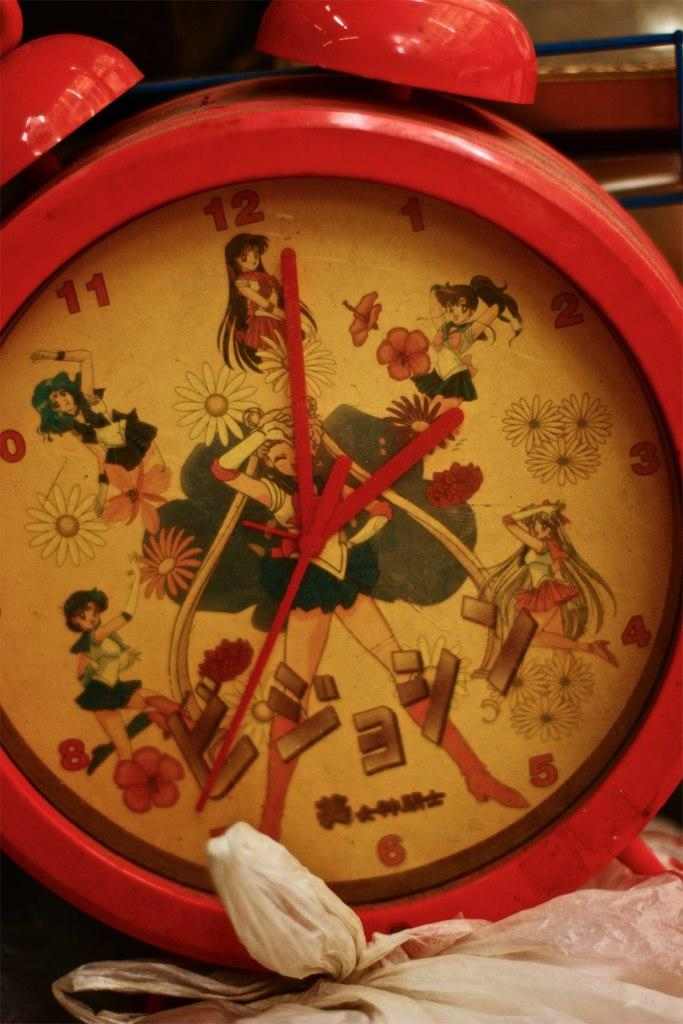<image>
Describe the image concisely. A Sailor Moon clock that is set to 2:01. 